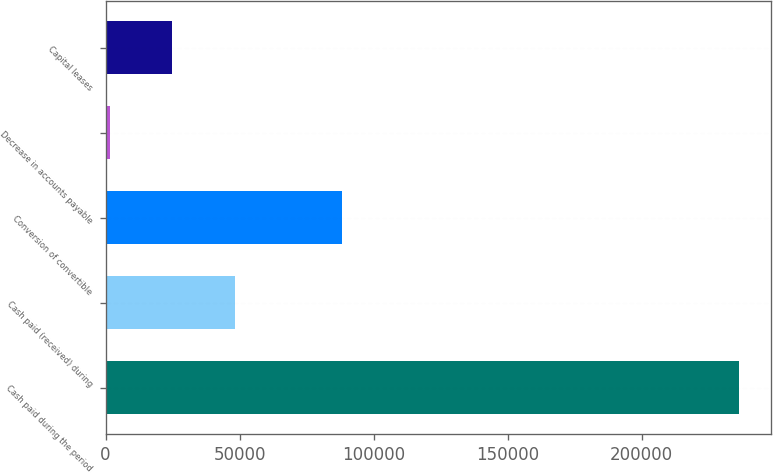<chart> <loc_0><loc_0><loc_500><loc_500><bar_chart><fcel>Cash paid during the period<fcel>Cash paid (received) during<fcel>Conversion of convertible<fcel>Decrease in accounts payable<fcel>Capital leases<nl><fcel>236389<fcel>48457<fcel>88085<fcel>1474<fcel>24965.5<nl></chart> 